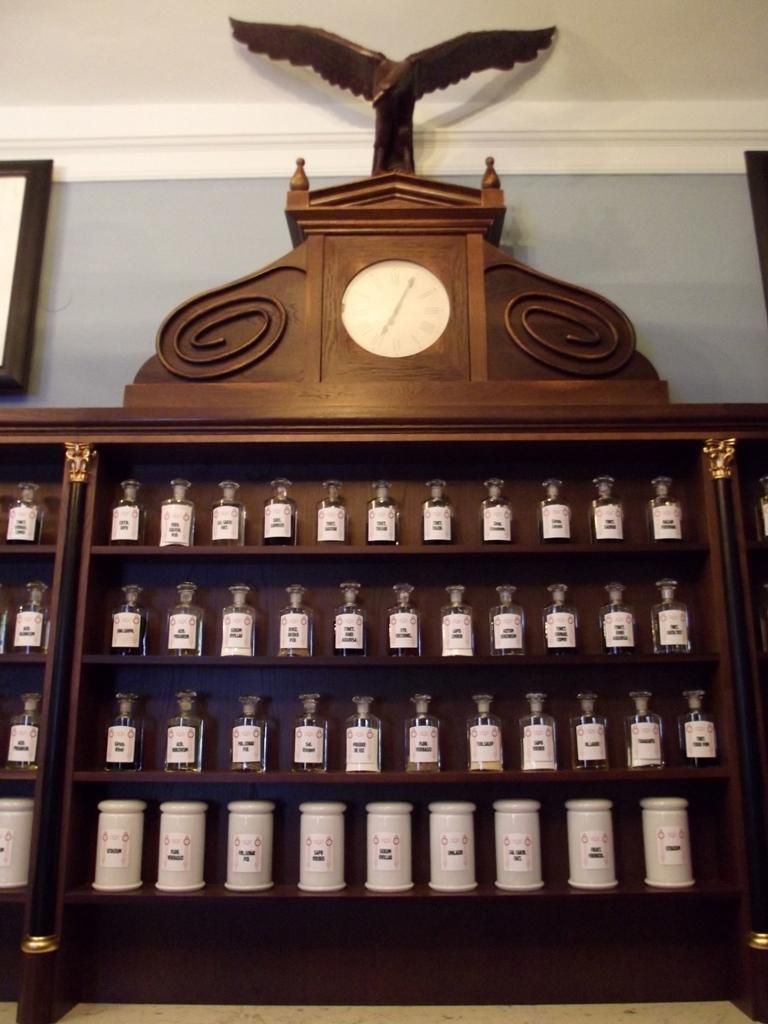What is the main object in the image? There is a rack in the image. What is placed on the rack? There are flasks and bottles on the rack. Is there any time-related object in the image? Yes, there is a clock in the image. What can be seen in the background of the image? There is a wall in the background of the image. What type of meat is being expanded in the image? There is no meat present in the image, nor is there any expansion occurring. 